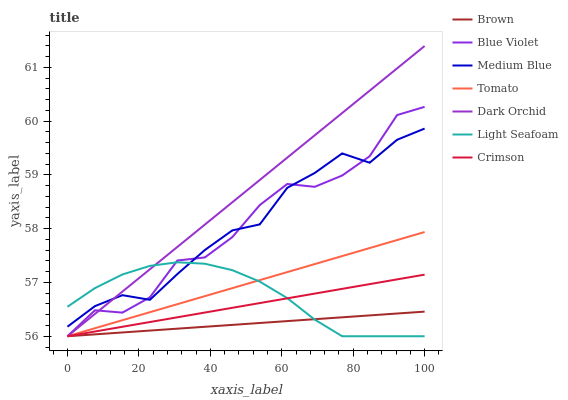Does Brown have the minimum area under the curve?
Answer yes or no. Yes. Does Dark Orchid have the maximum area under the curve?
Answer yes or no. Yes. Does Medium Blue have the minimum area under the curve?
Answer yes or no. No. Does Medium Blue have the maximum area under the curve?
Answer yes or no. No. Is Tomato the smoothest?
Answer yes or no. Yes. Is Blue Violet the roughest?
Answer yes or no. Yes. Is Brown the smoothest?
Answer yes or no. No. Is Brown the roughest?
Answer yes or no. No. Does Tomato have the lowest value?
Answer yes or no. Yes. Does Medium Blue have the lowest value?
Answer yes or no. No. Does Dark Orchid have the highest value?
Answer yes or no. Yes. Does Medium Blue have the highest value?
Answer yes or no. No. Is Tomato less than Medium Blue?
Answer yes or no. Yes. Is Medium Blue greater than Tomato?
Answer yes or no. Yes. Does Blue Violet intersect Medium Blue?
Answer yes or no. Yes. Is Blue Violet less than Medium Blue?
Answer yes or no. No. Is Blue Violet greater than Medium Blue?
Answer yes or no. No. Does Tomato intersect Medium Blue?
Answer yes or no. No. 